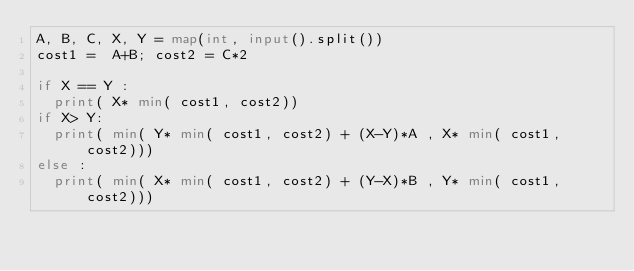Convert code to text. <code><loc_0><loc_0><loc_500><loc_500><_Python_>A, B, C, X, Y = map(int, input().split())
cost1 =  A+B; cost2 = C*2

if X == Y :
  print( X* min( cost1, cost2))
if X> Y:
  print( min( Y* min( cost1, cost2) + (X-Y)*A , X* min( cost1, cost2)))
else :
  print( min( X* min( cost1, cost2) + (Y-X)*B , Y* min( cost1, cost2)))
</code> 